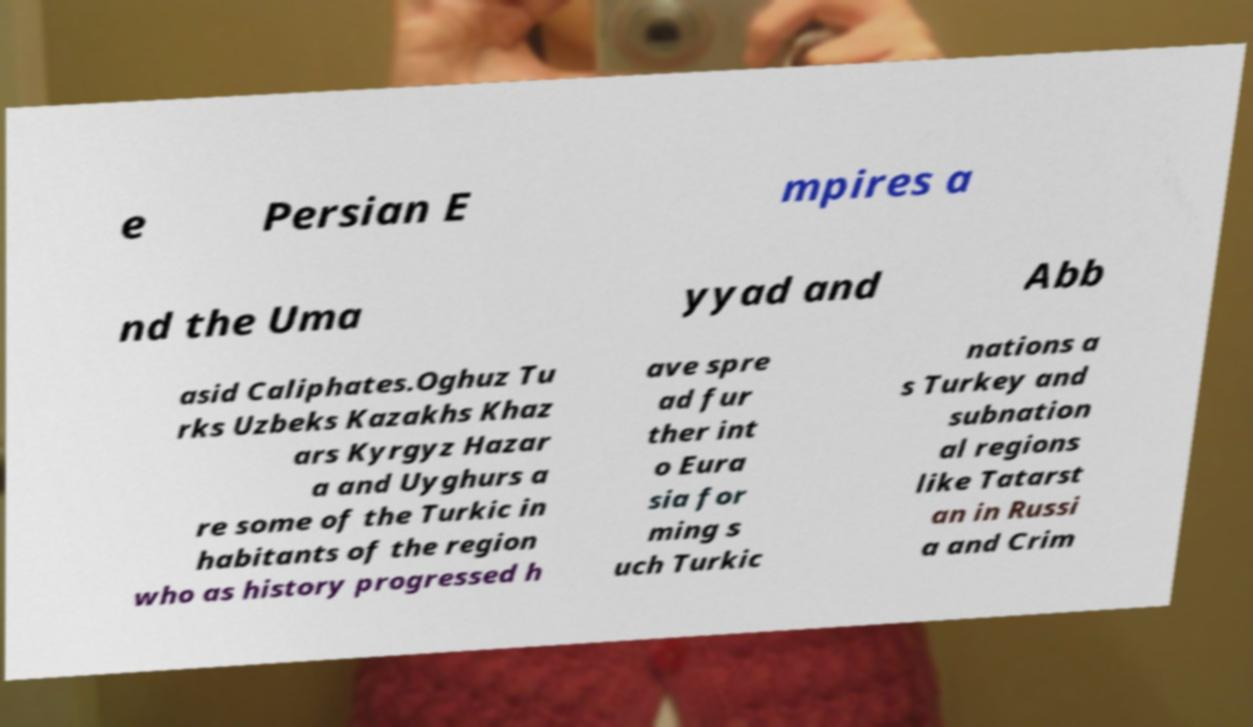Could you assist in decoding the text presented in this image and type it out clearly? e Persian E mpires a nd the Uma yyad and Abb asid Caliphates.Oghuz Tu rks Uzbeks Kazakhs Khaz ars Kyrgyz Hazar a and Uyghurs a re some of the Turkic in habitants of the region who as history progressed h ave spre ad fur ther int o Eura sia for ming s uch Turkic nations a s Turkey and subnation al regions like Tatarst an in Russi a and Crim 